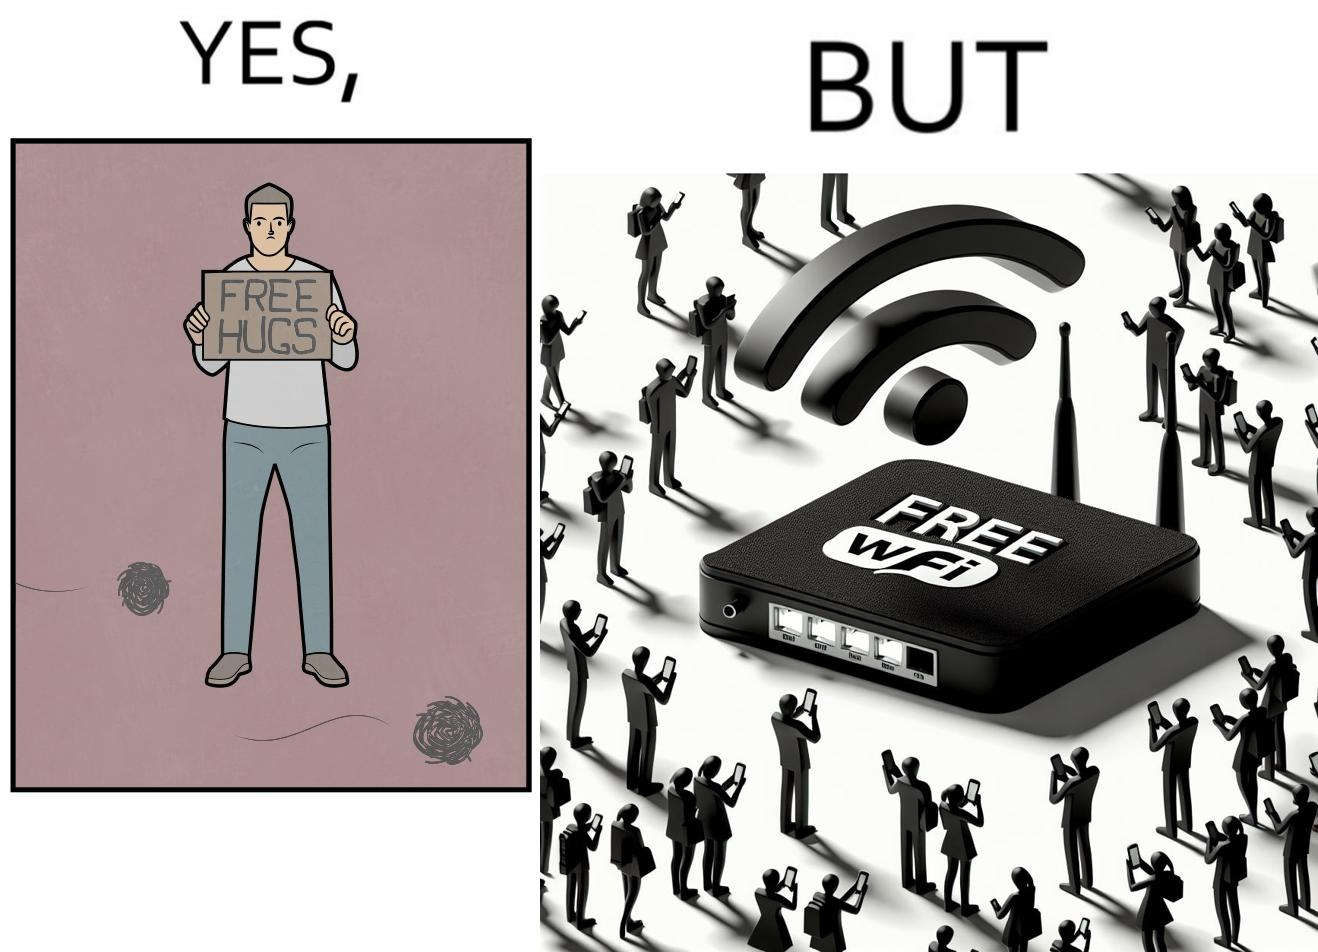What do you see in each half of this image? In the left part of the image: a person standing alone holding a sign "Free Hugs". The tumbleweeds blowing in the wind further stress on the loneliness. In the right part of the image: A Wi-fi Router with the label "Free Wifi" in front of it, surrounded by people trying to connect to it on their mobile devices. 